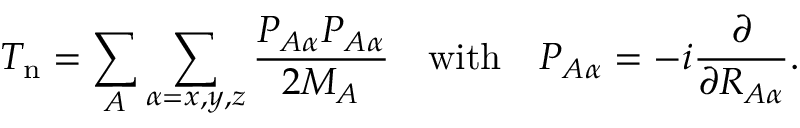Convert formula to latex. <formula><loc_0><loc_0><loc_500><loc_500>T _ { n } = \sum _ { A } \sum _ { \alpha = x , y , z } { \frac { P _ { A \alpha } P _ { A \alpha } } { 2 M _ { A } } } \quad w i t h \quad P _ { A \alpha } = - i { \frac { \partial } { \partial R _ { A \alpha } } } .</formula> 